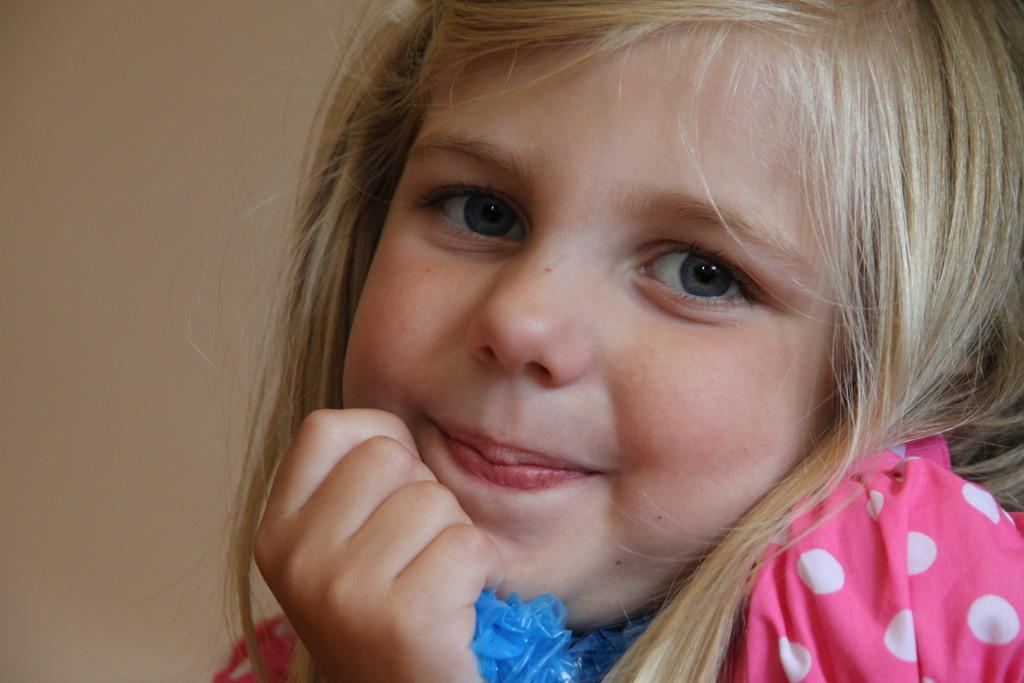Who is the main subject in the image? There is a girl in the image. What type of creature is the girl interacting with in the image? There is no creature present in the image; the girl is the only subject. What is the girl thinking about in the image? We cannot determine what the girl is thinking about in the image, as thoughts are not visible. 